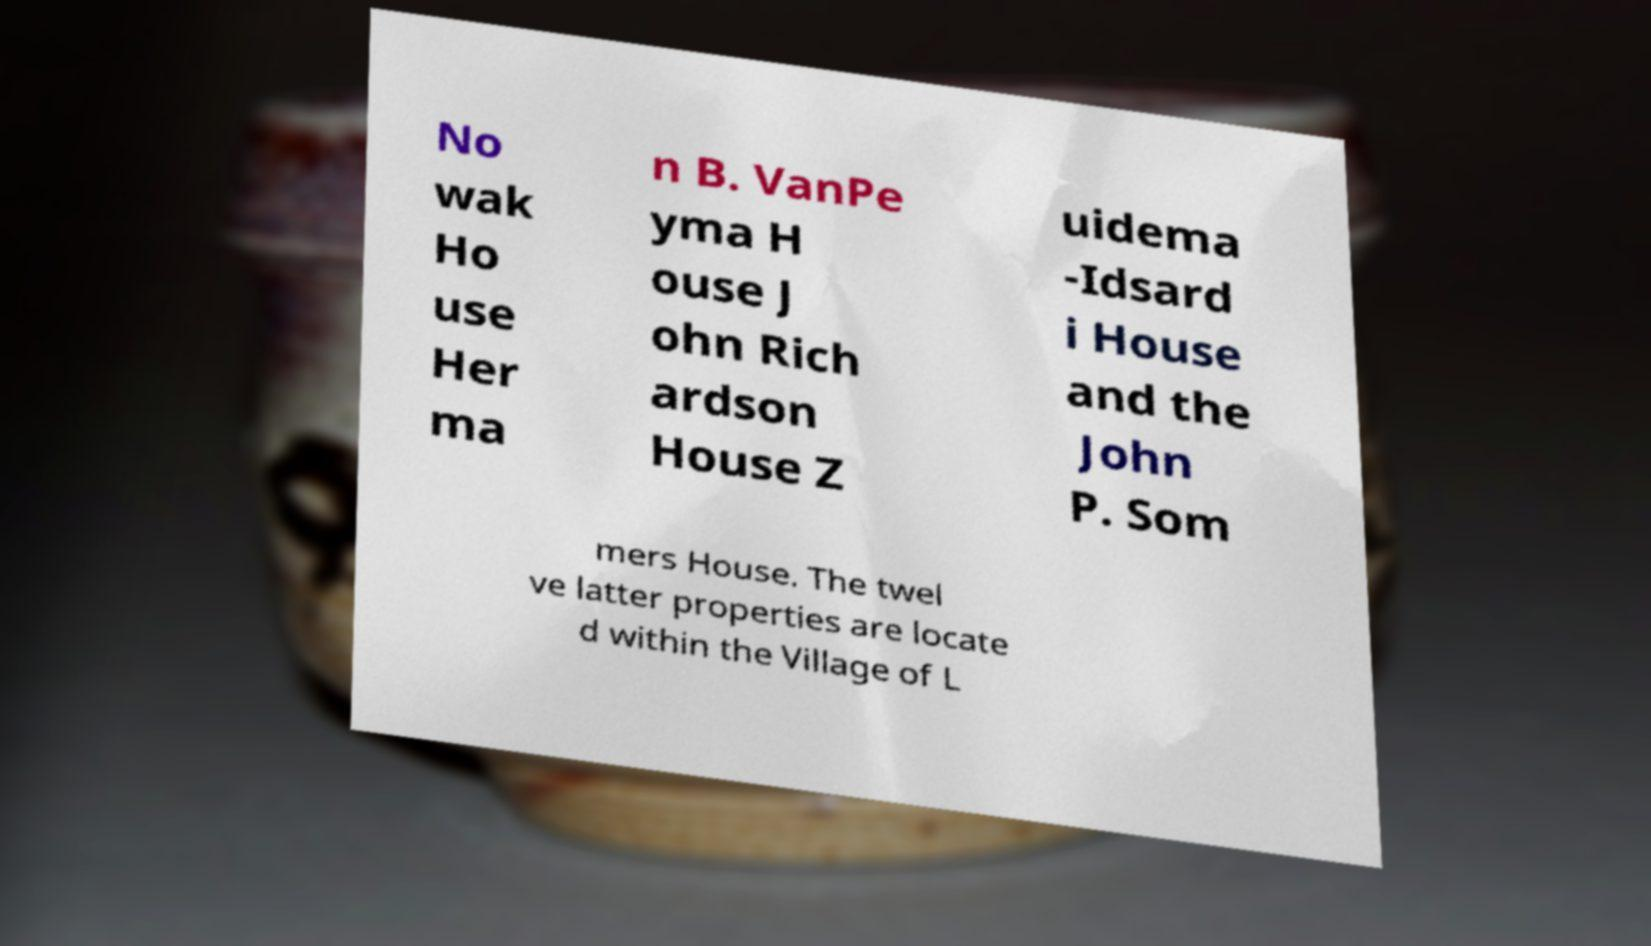What messages or text are displayed in this image? I need them in a readable, typed format. No wak Ho use Her ma n B. VanPe yma H ouse J ohn Rich ardson House Z uidema -Idsard i House and the John P. Som mers House. The twel ve latter properties are locate d within the Village of L 